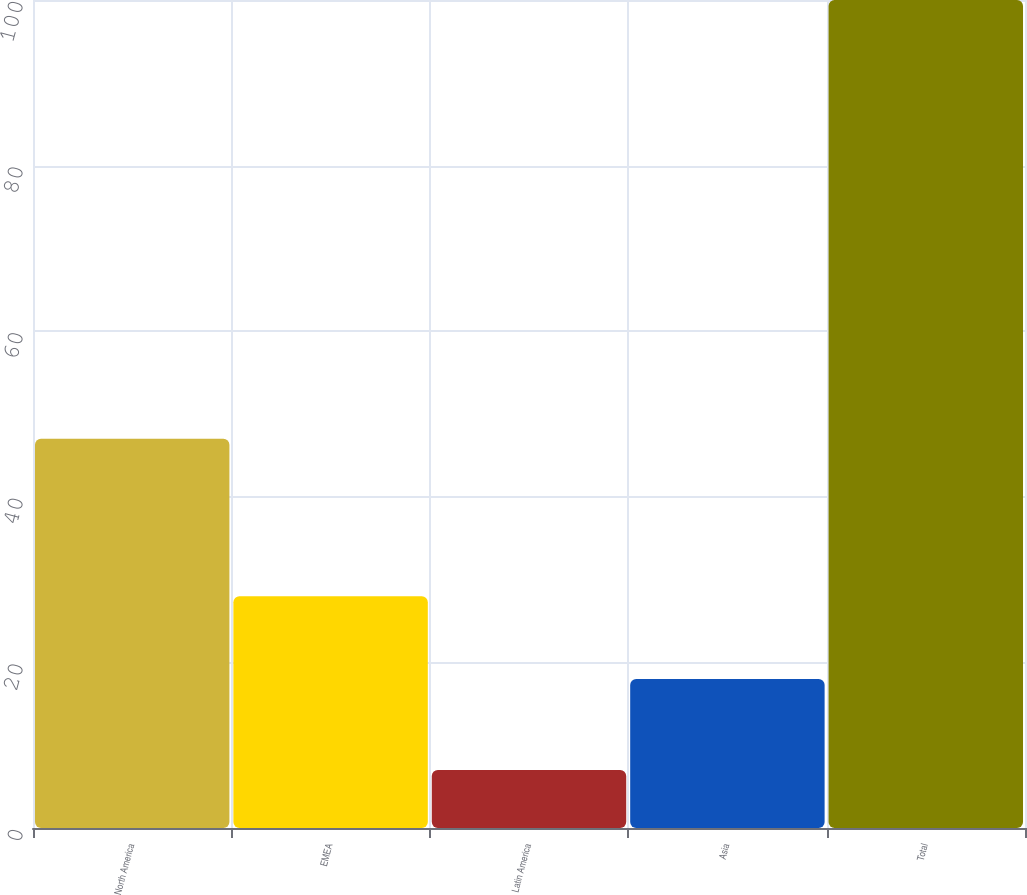Convert chart. <chart><loc_0><loc_0><loc_500><loc_500><bar_chart><fcel>North America<fcel>EMEA<fcel>Latin America<fcel>Asia<fcel>Total<nl><fcel>47<fcel>28<fcel>7<fcel>18<fcel>100<nl></chart> 